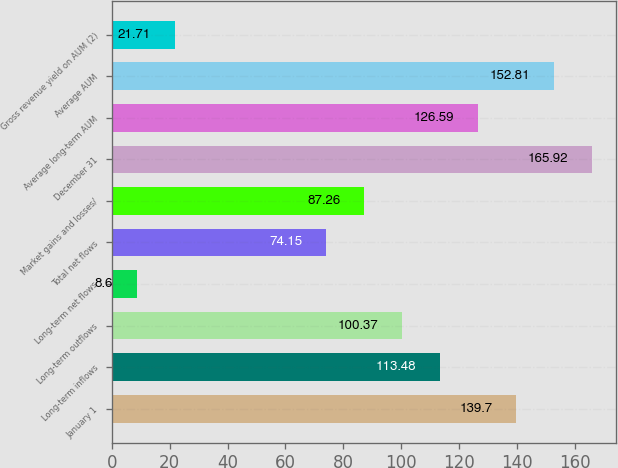Convert chart to OTSL. <chart><loc_0><loc_0><loc_500><loc_500><bar_chart><fcel>January 1<fcel>Long-term inflows<fcel>Long-term outflows<fcel>Long-term net flows<fcel>Total net flows<fcel>Market gains and losses/<fcel>December 31<fcel>Average long-term AUM<fcel>Average AUM<fcel>Gross revenue yield on AUM (2)<nl><fcel>139.7<fcel>113.48<fcel>100.37<fcel>8.6<fcel>74.15<fcel>87.26<fcel>165.92<fcel>126.59<fcel>152.81<fcel>21.71<nl></chart> 